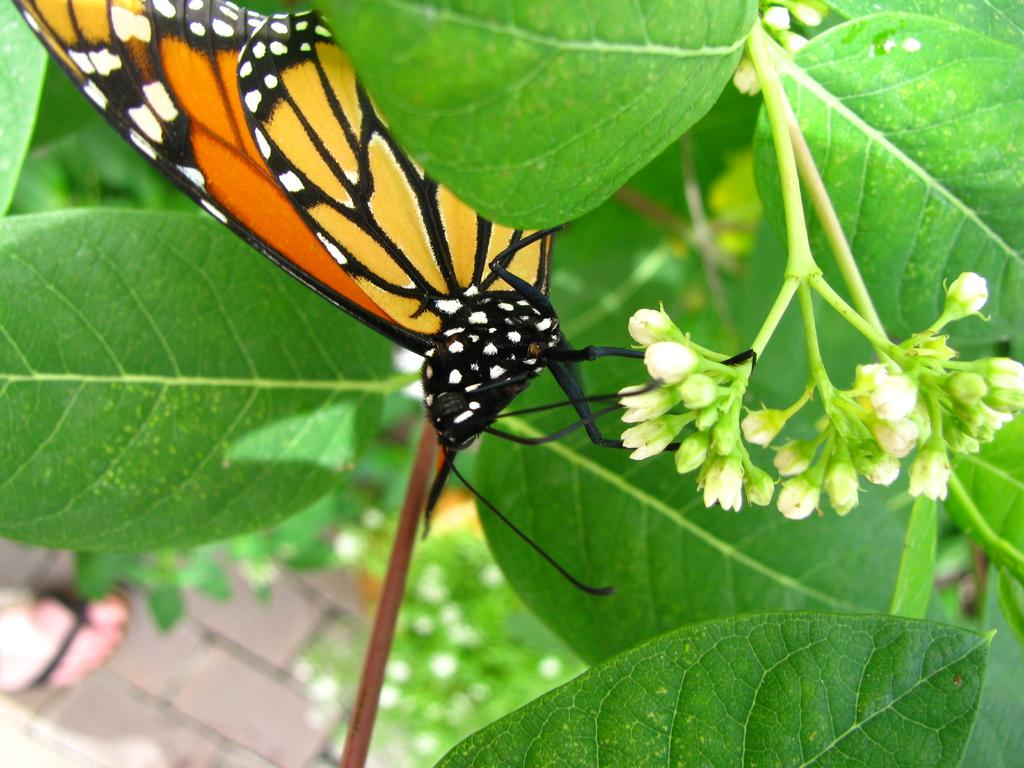What is the main subject of the image? There is a butterfly in the image. Where is the butterfly located? The butterfly is on the leaves. Can you describe the background of the image? The background of the image is blurred. What type of wool is being used to play basketball in the image? There is no wool or basketball present in the image; it features a butterfly on leaves with a blurred background. 